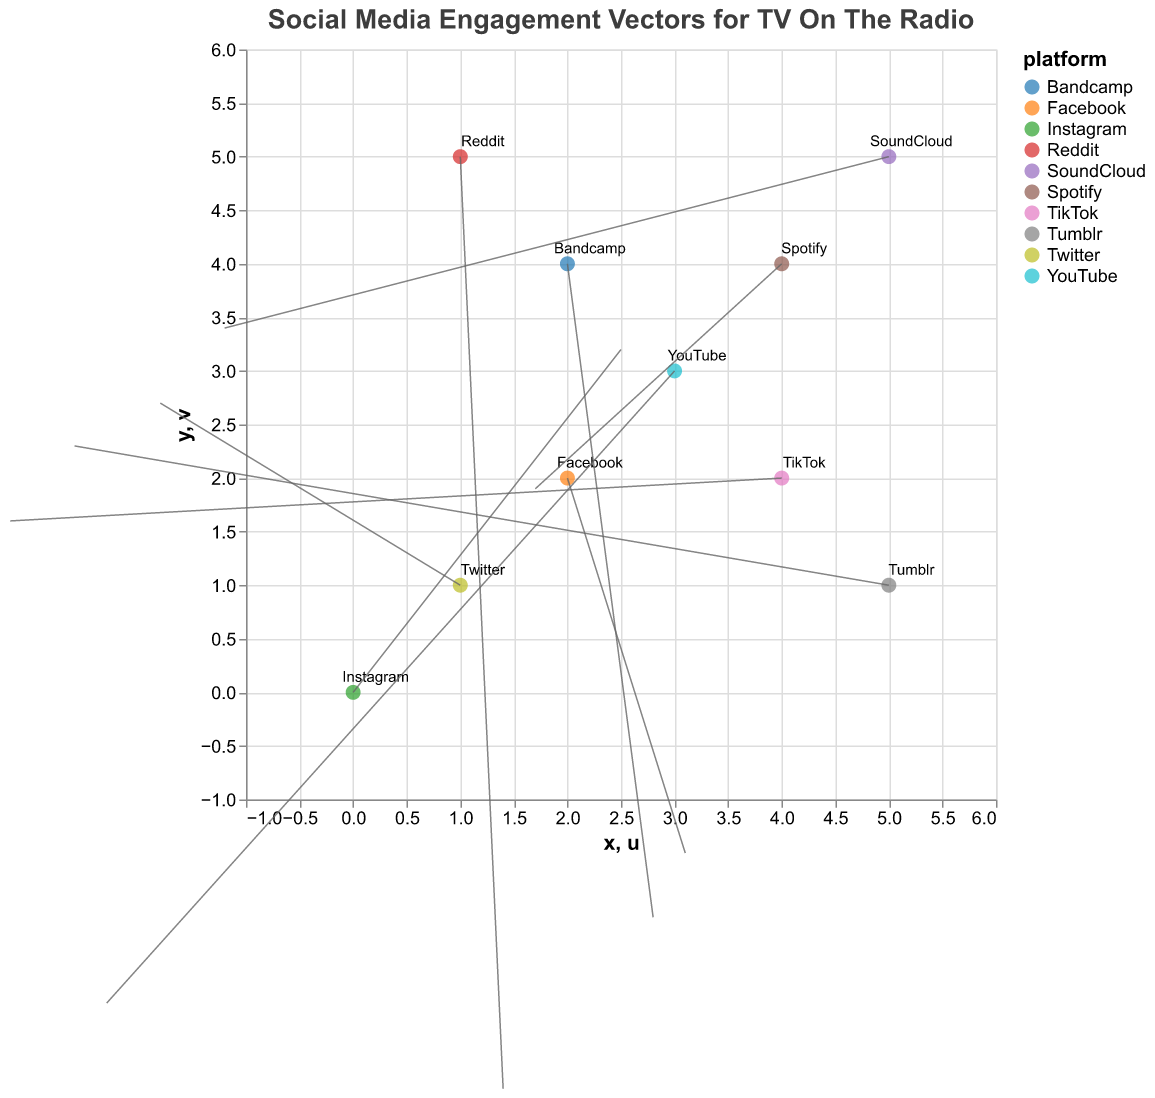What is the title of the plot? The title of the plot is typically the most prominent text at the top of the figure. It encapsulates the overall purpose of the visualization.
Answer: Social Media Engagement Vectors for TV On The Radio How many data points are present in the plot? Count the number of vectors or starting points in the plot. Each data point is marked by a platform name and a vector.
Answer: 10 Which platform has the highest positive x-direction engagement? Look for the vector with the highest positive value in the x-direction by examining the u values.
Answer: Facebook (u = 3.1) What is the average of the u values for Instagram and Facebook? Find the u values for Instagram and Facebook (2.5 and 3.1, respectively), then calculate the average: (2.5 + 3.1) / 2 = 2.8.
Answer: 2.8 Which platform has a downward y-direction vector starting at (1,1)? Identify the vector that starts at (1,1) and check if the corresponding v value is positive.
Answer: Twitter What is the difference in the x-direction vector components between YouTube and Tumblr? Find the u values for YouTube (-2.3) and Tumblr (-2.6), then calculate their difference: -2.3 - (-2.6) = 0.3.
Answer: 0.3 Which platform has the longest engagement vector? Calculate the magnitude of each vector as sqrt(u^2 + v^2) and find the platform with the highest value. SoundCloud's vector is longest: sqrt((-1.2)^2 + 3.4^2) = sqrt(1.44 + 11.56) ≈ 3.6.
Answer: SoundCloud Which two platforms have the shortest distance between their starting points? Calculate the Euclidean distance between each pair of starting points and identify the pair with the smallest distance. TikTok (4,2) and Facebook (2,2) have the shortest distance: sqrt((4-2)^2 + (2-2)^2) = sqrt(4) = 2.
Answer: TikTok and Facebook What is the total sum of the y-direction components of all platforms? Sum the v values for all platforms: 3.2 + 2.7 - 1.5 - 2.9 + 1.9 + 3.4 - 2.1 + 1.6 - 3.7 + 2.3 = 4.9.
Answer: 4.9 